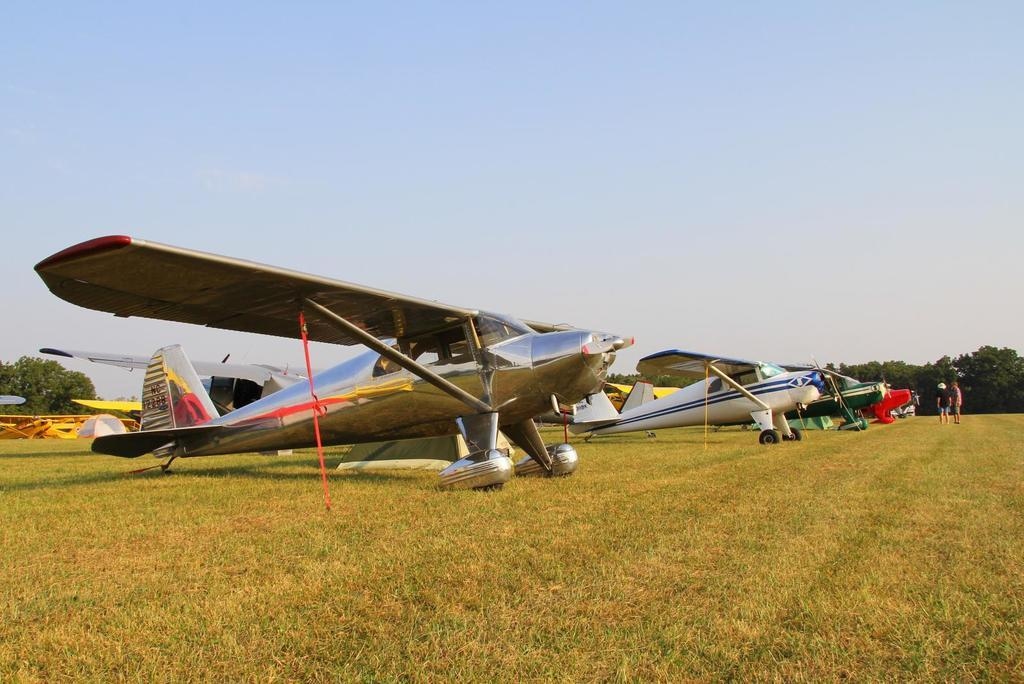What is the main subject of the image? The main subject of the image is many aircraft on the grass. What can be seen in the background of the image? In the background, there are trees, people, and the sky. What type of drug can be seen growing on the trees in the background? There is no drug growing on the trees in the background; the image only shows aircraft on the grass and trees, people, and the sky in the background. 